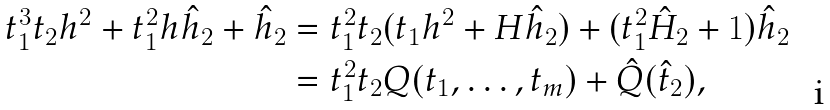<formula> <loc_0><loc_0><loc_500><loc_500>t _ { 1 } ^ { 3 } t _ { 2 } h ^ { 2 } + t _ { 1 } ^ { 2 } h \hat { h } _ { 2 } + \hat { h } _ { 2 } & = t _ { 1 } ^ { 2 } t _ { 2 } ( t _ { 1 } h ^ { 2 } + H \hat { h } _ { 2 } ) + ( t _ { 1 } ^ { 2 } \hat { H } _ { 2 } + 1 ) \hat { h } _ { 2 } \\ & = t _ { 1 } ^ { 2 } t _ { 2 } Q ( t _ { 1 } , \dots , t _ { m } ) + \hat { Q } ( \hat { t } _ { 2 } ) ,</formula> 